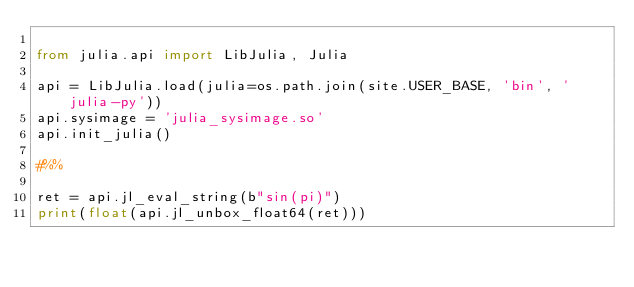Convert code to text. <code><loc_0><loc_0><loc_500><loc_500><_Python_>
from julia.api import LibJulia, Julia

api = LibJulia.load(julia=os.path.join(site.USER_BASE, 'bin', 'julia-py'))
api.sysimage = 'julia_sysimage.so'
api.init_julia()

#%%

ret = api.jl_eval_string(b"sin(pi)")
print(float(api.jl_unbox_float64(ret)))
</code> 